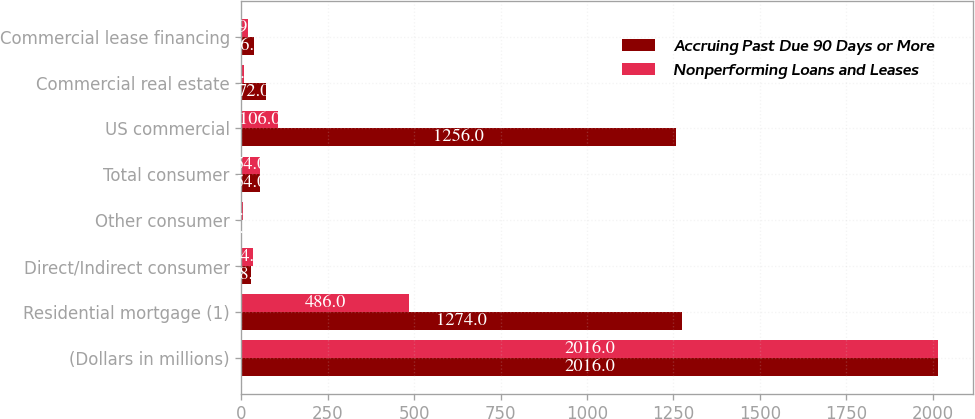<chart> <loc_0><loc_0><loc_500><loc_500><stacked_bar_chart><ecel><fcel>(Dollars in millions)<fcel>Residential mortgage (1)<fcel>Direct/Indirect consumer<fcel>Other consumer<fcel>Total consumer<fcel>US commercial<fcel>Commercial real estate<fcel>Commercial lease financing<nl><fcel>Accruing Past Due 90 Days or More<fcel>2016<fcel>1274<fcel>28<fcel>2<fcel>54<fcel>1256<fcel>72<fcel>36<nl><fcel>Nonperforming Loans and Leases<fcel>2016<fcel>486<fcel>34<fcel>4<fcel>54<fcel>106<fcel>7<fcel>19<nl></chart> 